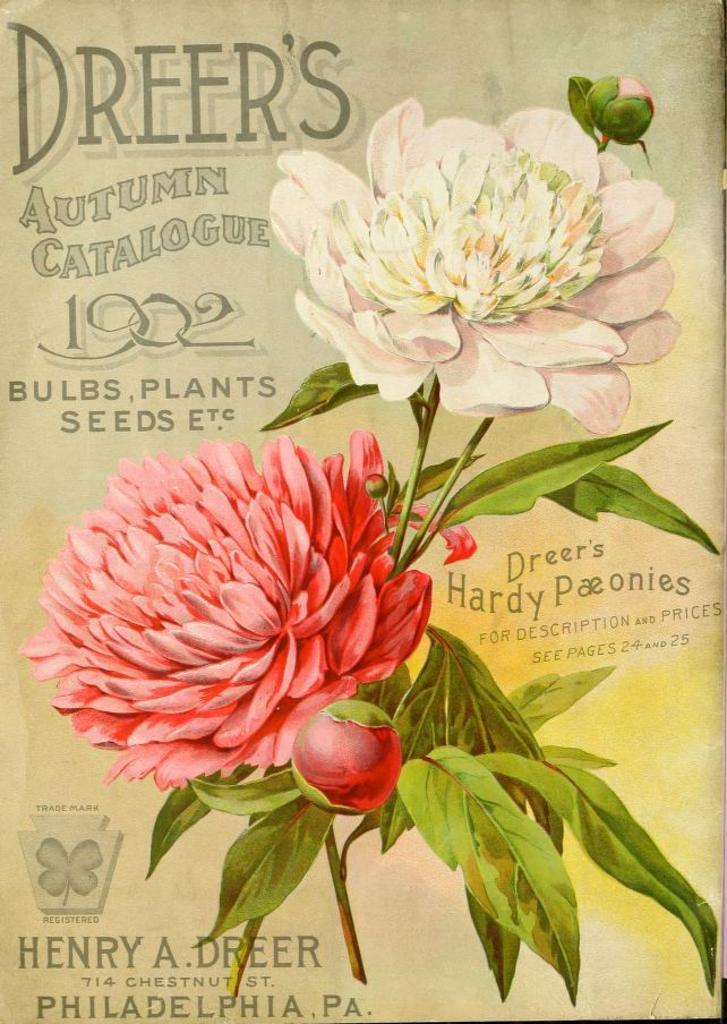What is the main subject of the painting in the image? The painting depicts two flowers. Can you describe the colors of the flowers? One flower is red, and the other is light pink. What stage of growth are the flowers in? The flowers have buds. Do the flowers have any other features besides the buds? Yes, the flowers have leaves. What is written at the top of the painting? The words "Dreyer's" are written at the top of the painting. What type of desk is visible in the image? There is no desk present in the image; it features a painting of two flowers. What is the title of the painting in the image? The provided facts do not mention a title for the painting. 